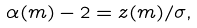<formula> <loc_0><loc_0><loc_500><loc_500>\alpha ( m ) - 2 = z ( m ) / \sigma ,</formula> 